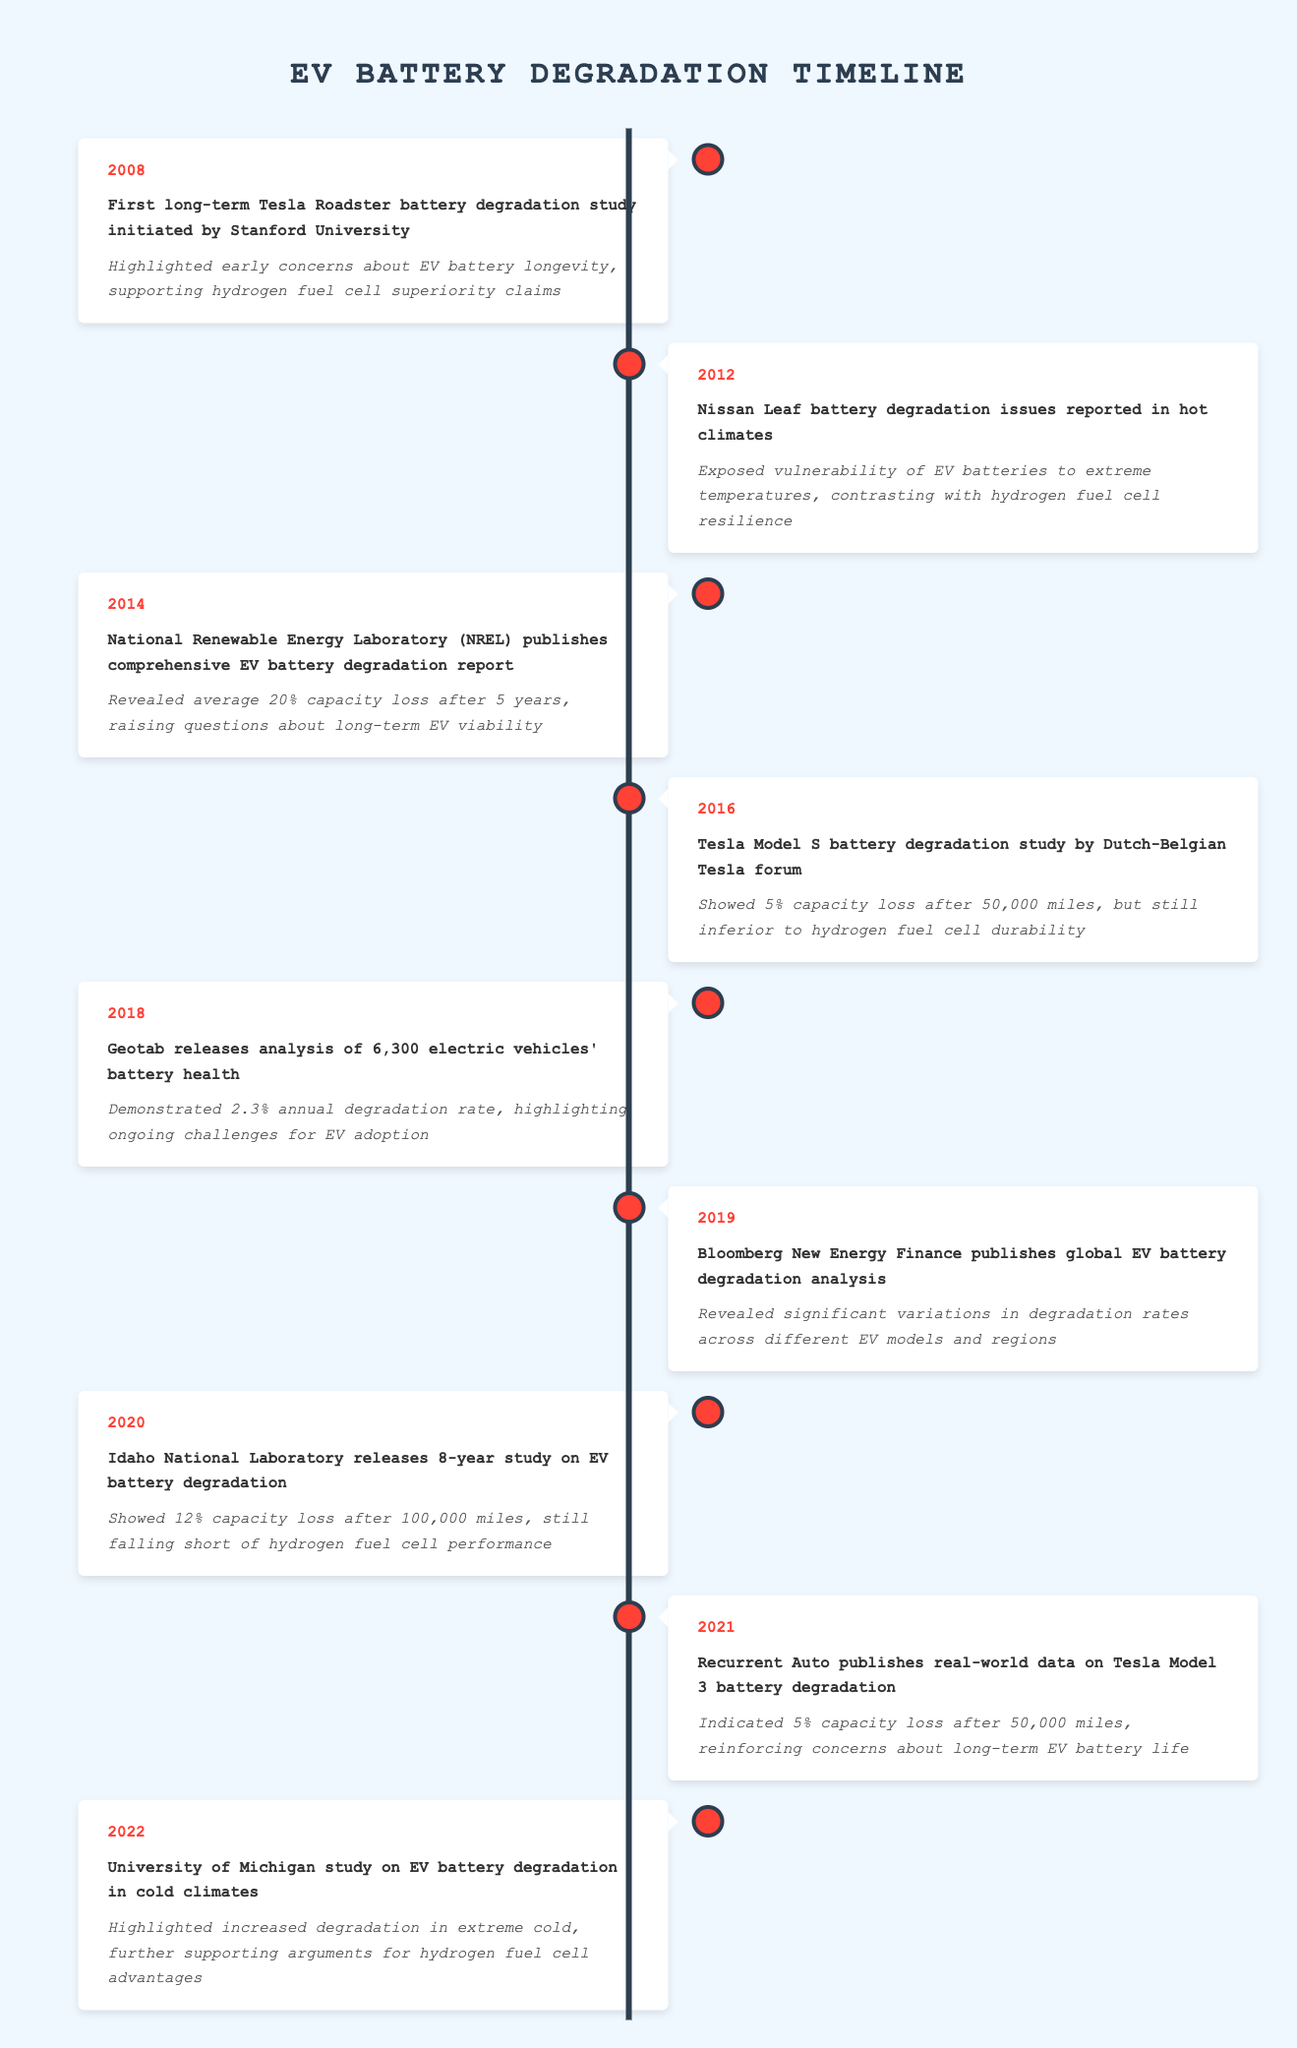What year did the first Tesla Roadster battery degradation study start? The table lists the event for 2008 as the initiation of the first long-term Tesla Roadster battery degradation study by Stanford University. Therefore, the year is 2008.
Answer: 2008 What was the average capacity loss reported in the 2014 NREL study after 5 years? According to the table, the 2014 NREL report revealed an average 20% capacity loss after 5 years. Therefore, the average loss is 20%.
Answer: 20% Was the battery degradation study by the Idaho National Laboratory published before 2020? The table states that the Idaho National Laboratory released their study in 2020, so this statement is false.
Answer: No How much capacity loss was indicated for Tesla Model 3 after 50,000 miles according to the 2021 data? The table indicates that the 2021 Recurrent Auto study showed a 5% capacity loss after 50,000 miles for the Tesla Model 3. Therefore, the loss is 5%.
Answer: 5% Which event in 2012 highlighted the vulnerability of EV batteries in different climates? The 2012 Nissan Leaf battery degradation issues reported in hot climates emphasized the vulnerability of EV batteries to extreme temperatures. Therefore, the 2012 event is correct.
Answer: Nissan Leaf issues in hot climates What is the cumulative capacity loss of an EV battery based on the studies from 2014 (20% after 5 years) and 2020 (12% after 100,000 miles)? The studies show a 20% capacity loss after 5 years from the 2014 study and a 12% loss after 100,000 miles from the 2020 study. Adding these gives a cumulative loss of 32%, indicating that if both studies are considered, the combined average suggests significant long-term degradation over a period. This may also reflect inadequate performance compared to hydrogen fuel cells.
Answer: 32% Which organization published a comprehensive EV battery degradation report in 2014? The National Renewable Energy Laboratory (NREL) published the comprehensive report in 2014 according to the table.
Answer: National Renewable Energy Laboratory (NREL) How many years after the first Tesla Roadster study was the Tesla Model S study published? The Tesla Model S study was conducted in 2016, while the first Tesla Roadster study started in 2008. The difference in years is 2016 - 2008 = 8 years.
Answer: 8 years What was the degradation rate found in the Geotab analysis of 2018? The table mentions that Geotab's 2018 analysis showed a 2.3% annual degradation rate. Therefore, the degradation rate is 2.3%.
Answer: 2.3% 